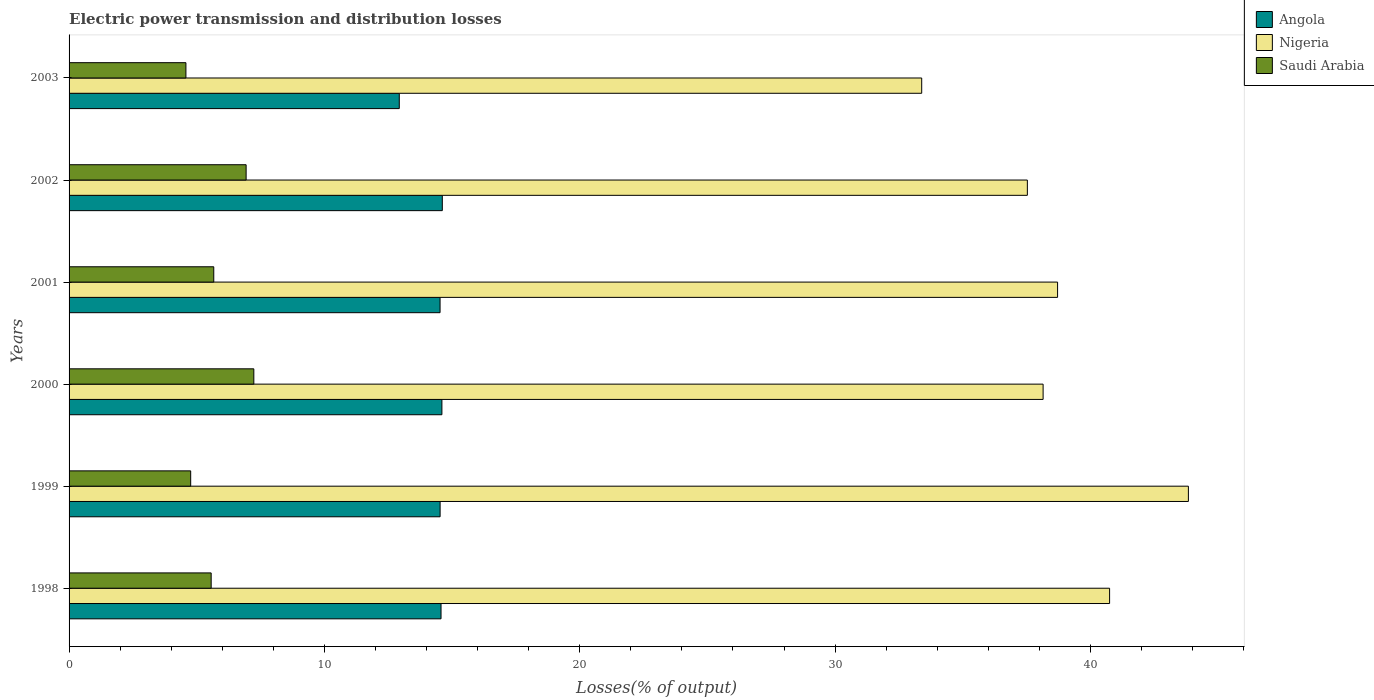How many different coloured bars are there?
Give a very brief answer. 3. How many groups of bars are there?
Offer a terse response. 6. Are the number of bars on each tick of the Y-axis equal?
Ensure brevity in your answer.  Yes. In how many cases, is the number of bars for a given year not equal to the number of legend labels?
Your answer should be compact. 0. What is the electric power transmission and distribution losses in Saudi Arabia in 2002?
Your answer should be very brief. 6.93. Across all years, what is the maximum electric power transmission and distribution losses in Saudi Arabia?
Your answer should be very brief. 7.24. Across all years, what is the minimum electric power transmission and distribution losses in Saudi Arabia?
Keep it short and to the point. 4.58. What is the total electric power transmission and distribution losses in Angola in the graph?
Your answer should be compact. 85.78. What is the difference between the electric power transmission and distribution losses in Saudi Arabia in 1999 and that in 2001?
Ensure brevity in your answer.  -0.9. What is the difference between the electric power transmission and distribution losses in Saudi Arabia in 1998 and the electric power transmission and distribution losses in Angola in 2002?
Make the answer very short. -9.05. What is the average electric power transmission and distribution losses in Saudi Arabia per year?
Your response must be concise. 5.79. In the year 1998, what is the difference between the electric power transmission and distribution losses in Angola and electric power transmission and distribution losses in Saudi Arabia?
Give a very brief answer. 9. What is the ratio of the electric power transmission and distribution losses in Nigeria in 2000 to that in 2001?
Your response must be concise. 0.99. What is the difference between the highest and the second highest electric power transmission and distribution losses in Saudi Arabia?
Your response must be concise. 0.3. What is the difference between the highest and the lowest electric power transmission and distribution losses in Nigeria?
Offer a very short reply. 10.44. In how many years, is the electric power transmission and distribution losses in Saudi Arabia greater than the average electric power transmission and distribution losses in Saudi Arabia taken over all years?
Provide a succinct answer. 2. What does the 2nd bar from the top in 2001 represents?
Offer a very short reply. Nigeria. What does the 2nd bar from the bottom in 2002 represents?
Provide a succinct answer. Nigeria. What is the difference between two consecutive major ticks on the X-axis?
Your answer should be compact. 10. Does the graph contain grids?
Provide a succinct answer. No. Where does the legend appear in the graph?
Provide a succinct answer. Top right. How many legend labels are there?
Ensure brevity in your answer.  3. What is the title of the graph?
Provide a succinct answer. Electric power transmission and distribution losses. What is the label or title of the X-axis?
Keep it short and to the point. Losses(% of output). What is the label or title of the Y-axis?
Provide a short and direct response. Years. What is the Losses(% of output) in Angola in 1998?
Your answer should be compact. 14.57. What is the Losses(% of output) in Nigeria in 1998?
Offer a very short reply. 40.75. What is the Losses(% of output) in Saudi Arabia in 1998?
Offer a very short reply. 5.57. What is the Losses(% of output) of Angola in 1999?
Your answer should be very brief. 14.53. What is the Losses(% of output) in Nigeria in 1999?
Keep it short and to the point. 43.84. What is the Losses(% of output) in Saudi Arabia in 1999?
Give a very brief answer. 4.76. What is the Losses(% of output) of Angola in 2000?
Keep it short and to the point. 14.6. What is the Losses(% of output) in Nigeria in 2000?
Keep it short and to the point. 38.15. What is the Losses(% of output) of Saudi Arabia in 2000?
Provide a succinct answer. 7.24. What is the Losses(% of output) of Angola in 2001?
Your answer should be compact. 14.53. What is the Losses(% of output) in Nigeria in 2001?
Offer a very short reply. 38.71. What is the Losses(% of output) of Saudi Arabia in 2001?
Your answer should be very brief. 5.67. What is the Losses(% of output) of Angola in 2002?
Your answer should be compact. 14.62. What is the Losses(% of output) of Nigeria in 2002?
Ensure brevity in your answer.  37.53. What is the Losses(% of output) of Saudi Arabia in 2002?
Make the answer very short. 6.93. What is the Losses(% of output) of Angola in 2003?
Ensure brevity in your answer.  12.93. What is the Losses(% of output) of Nigeria in 2003?
Offer a very short reply. 33.39. What is the Losses(% of output) in Saudi Arabia in 2003?
Ensure brevity in your answer.  4.58. Across all years, what is the maximum Losses(% of output) of Angola?
Your response must be concise. 14.62. Across all years, what is the maximum Losses(% of output) of Nigeria?
Provide a short and direct response. 43.84. Across all years, what is the maximum Losses(% of output) in Saudi Arabia?
Ensure brevity in your answer.  7.24. Across all years, what is the minimum Losses(% of output) of Angola?
Your answer should be very brief. 12.93. Across all years, what is the minimum Losses(% of output) of Nigeria?
Offer a terse response. 33.39. Across all years, what is the minimum Losses(% of output) of Saudi Arabia?
Your answer should be very brief. 4.58. What is the total Losses(% of output) of Angola in the graph?
Ensure brevity in your answer.  85.78. What is the total Losses(% of output) in Nigeria in the graph?
Ensure brevity in your answer.  232.37. What is the total Losses(% of output) in Saudi Arabia in the graph?
Provide a short and direct response. 34.74. What is the difference between the Losses(% of output) in Angola in 1998 and that in 1999?
Ensure brevity in your answer.  0.04. What is the difference between the Losses(% of output) in Nigeria in 1998 and that in 1999?
Your answer should be very brief. -3.09. What is the difference between the Losses(% of output) in Saudi Arabia in 1998 and that in 1999?
Your response must be concise. 0.8. What is the difference between the Losses(% of output) in Angola in 1998 and that in 2000?
Ensure brevity in your answer.  -0.03. What is the difference between the Losses(% of output) of Nigeria in 1998 and that in 2000?
Your answer should be compact. 2.6. What is the difference between the Losses(% of output) in Saudi Arabia in 1998 and that in 2000?
Offer a very short reply. -1.67. What is the difference between the Losses(% of output) in Angola in 1998 and that in 2001?
Your answer should be compact. 0.04. What is the difference between the Losses(% of output) in Nigeria in 1998 and that in 2001?
Keep it short and to the point. 2.04. What is the difference between the Losses(% of output) in Saudi Arabia in 1998 and that in 2001?
Your answer should be very brief. -0.1. What is the difference between the Losses(% of output) in Nigeria in 1998 and that in 2002?
Give a very brief answer. 3.22. What is the difference between the Losses(% of output) in Saudi Arabia in 1998 and that in 2002?
Provide a short and direct response. -1.37. What is the difference between the Losses(% of output) of Angola in 1998 and that in 2003?
Your response must be concise. 1.64. What is the difference between the Losses(% of output) in Nigeria in 1998 and that in 2003?
Ensure brevity in your answer.  7.36. What is the difference between the Losses(% of output) in Saudi Arabia in 1998 and that in 2003?
Your answer should be compact. 0.99. What is the difference between the Losses(% of output) of Angola in 1999 and that in 2000?
Offer a very short reply. -0.07. What is the difference between the Losses(% of output) in Nigeria in 1999 and that in 2000?
Offer a very short reply. 5.69. What is the difference between the Losses(% of output) of Saudi Arabia in 1999 and that in 2000?
Provide a short and direct response. -2.47. What is the difference between the Losses(% of output) of Angola in 1999 and that in 2001?
Your answer should be compact. 0. What is the difference between the Losses(% of output) in Nigeria in 1999 and that in 2001?
Your answer should be very brief. 5.12. What is the difference between the Losses(% of output) in Saudi Arabia in 1999 and that in 2001?
Offer a terse response. -0.9. What is the difference between the Losses(% of output) in Angola in 1999 and that in 2002?
Your answer should be very brief. -0.09. What is the difference between the Losses(% of output) of Nigeria in 1999 and that in 2002?
Offer a terse response. 6.31. What is the difference between the Losses(% of output) of Saudi Arabia in 1999 and that in 2002?
Offer a terse response. -2.17. What is the difference between the Losses(% of output) of Angola in 1999 and that in 2003?
Offer a terse response. 1.6. What is the difference between the Losses(% of output) of Nigeria in 1999 and that in 2003?
Offer a terse response. 10.44. What is the difference between the Losses(% of output) of Saudi Arabia in 1999 and that in 2003?
Offer a very short reply. 0.19. What is the difference between the Losses(% of output) of Angola in 2000 and that in 2001?
Ensure brevity in your answer.  0.07. What is the difference between the Losses(% of output) in Nigeria in 2000 and that in 2001?
Provide a short and direct response. -0.57. What is the difference between the Losses(% of output) in Saudi Arabia in 2000 and that in 2001?
Make the answer very short. 1.57. What is the difference between the Losses(% of output) of Angola in 2000 and that in 2002?
Provide a succinct answer. -0.02. What is the difference between the Losses(% of output) in Nigeria in 2000 and that in 2002?
Offer a terse response. 0.62. What is the difference between the Losses(% of output) of Saudi Arabia in 2000 and that in 2002?
Make the answer very short. 0.3. What is the difference between the Losses(% of output) of Angola in 2000 and that in 2003?
Your answer should be very brief. 1.67. What is the difference between the Losses(% of output) in Nigeria in 2000 and that in 2003?
Offer a very short reply. 4.75. What is the difference between the Losses(% of output) in Saudi Arabia in 2000 and that in 2003?
Provide a succinct answer. 2.66. What is the difference between the Losses(% of output) of Angola in 2001 and that in 2002?
Offer a very short reply. -0.09. What is the difference between the Losses(% of output) of Nigeria in 2001 and that in 2002?
Give a very brief answer. 1.18. What is the difference between the Losses(% of output) in Saudi Arabia in 2001 and that in 2002?
Your answer should be compact. -1.27. What is the difference between the Losses(% of output) of Angola in 2001 and that in 2003?
Your answer should be very brief. 1.6. What is the difference between the Losses(% of output) in Nigeria in 2001 and that in 2003?
Your response must be concise. 5.32. What is the difference between the Losses(% of output) of Saudi Arabia in 2001 and that in 2003?
Your answer should be compact. 1.09. What is the difference between the Losses(% of output) of Angola in 2002 and that in 2003?
Provide a succinct answer. 1.69. What is the difference between the Losses(% of output) in Nigeria in 2002 and that in 2003?
Your answer should be compact. 4.14. What is the difference between the Losses(% of output) of Saudi Arabia in 2002 and that in 2003?
Offer a very short reply. 2.36. What is the difference between the Losses(% of output) of Angola in 1998 and the Losses(% of output) of Nigeria in 1999?
Offer a very short reply. -29.27. What is the difference between the Losses(% of output) in Angola in 1998 and the Losses(% of output) in Saudi Arabia in 1999?
Keep it short and to the point. 9.8. What is the difference between the Losses(% of output) of Nigeria in 1998 and the Losses(% of output) of Saudi Arabia in 1999?
Your answer should be compact. 35.99. What is the difference between the Losses(% of output) in Angola in 1998 and the Losses(% of output) in Nigeria in 2000?
Your response must be concise. -23.58. What is the difference between the Losses(% of output) of Angola in 1998 and the Losses(% of output) of Saudi Arabia in 2000?
Give a very brief answer. 7.33. What is the difference between the Losses(% of output) of Nigeria in 1998 and the Losses(% of output) of Saudi Arabia in 2000?
Provide a succinct answer. 33.52. What is the difference between the Losses(% of output) of Angola in 1998 and the Losses(% of output) of Nigeria in 2001?
Your answer should be very brief. -24.15. What is the difference between the Losses(% of output) in Angola in 1998 and the Losses(% of output) in Saudi Arabia in 2001?
Offer a terse response. 8.9. What is the difference between the Losses(% of output) of Nigeria in 1998 and the Losses(% of output) of Saudi Arabia in 2001?
Keep it short and to the point. 35.09. What is the difference between the Losses(% of output) of Angola in 1998 and the Losses(% of output) of Nigeria in 2002?
Your response must be concise. -22.96. What is the difference between the Losses(% of output) of Angola in 1998 and the Losses(% of output) of Saudi Arabia in 2002?
Make the answer very short. 7.63. What is the difference between the Losses(% of output) of Nigeria in 1998 and the Losses(% of output) of Saudi Arabia in 2002?
Your response must be concise. 33.82. What is the difference between the Losses(% of output) of Angola in 1998 and the Losses(% of output) of Nigeria in 2003?
Offer a terse response. -18.83. What is the difference between the Losses(% of output) in Angola in 1998 and the Losses(% of output) in Saudi Arabia in 2003?
Provide a succinct answer. 9.99. What is the difference between the Losses(% of output) in Nigeria in 1998 and the Losses(% of output) in Saudi Arabia in 2003?
Keep it short and to the point. 36.18. What is the difference between the Losses(% of output) in Angola in 1999 and the Losses(% of output) in Nigeria in 2000?
Keep it short and to the point. -23.62. What is the difference between the Losses(% of output) of Angola in 1999 and the Losses(% of output) of Saudi Arabia in 2000?
Provide a short and direct response. 7.3. What is the difference between the Losses(% of output) in Nigeria in 1999 and the Losses(% of output) in Saudi Arabia in 2000?
Ensure brevity in your answer.  36.6. What is the difference between the Losses(% of output) of Angola in 1999 and the Losses(% of output) of Nigeria in 2001?
Your answer should be compact. -24.18. What is the difference between the Losses(% of output) of Angola in 1999 and the Losses(% of output) of Saudi Arabia in 2001?
Your answer should be very brief. 8.87. What is the difference between the Losses(% of output) of Nigeria in 1999 and the Losses(% of output) of Saudi Arabia in 2001?
Keep it short and to the point. 38.17. What is the difference between the Losses(% of output) in Angola in 1999 and the Losses(% of output) in Nigeria in 2002?
Your answer should be compact. -23. What is the difference between the Losses(% of output) of Angola in 1999 and the Losses(% of output) of Saudi Arabia in 2002?
Your answer should be compact. 7.6. What is the difference between the Losses(% of output) in Nigeria in 1999 and the Losses(% of output) in Saudi Arabia in 2002?
Make the answer very short. 36.9. What is the difference between the Losses(% of output) in Angola in 1999 and the Losses(% of output) in Nigeria in 2003?
Your answer should be compact. -18.86. What is the difference between the Losses(% of output) of Angola in 1999 and the Losses(% of output) of Saudi Arabia in 2003?
Offer a terse response. 9.96. What is the difference between the Losses(% of output) in Nigeria in 1999 and the Losses(% of output) in Saudi Arabia in 2003?
Offer a very short reply. 39.26. What is the difference between the Losses(% of output) in Angola in 2000 and the Losses(% of output) in Nigeria in 2001?
Give a very brief answer. -24.11. What is the difference between the Losses(% of output) of Angola in 2000 and the Losses(% of output) of Saudi Arabia in 2001?
Your answer should be compact. 8.94. What is the difference between the Losses(% of output) in Nigeria in 2000 and the Losses(% of output) in Saudi Arabia in 2001?
Keep it short and to the point. 32.48. What is the difference between the Losses(% of output) of Angola in 2000 and the Losses(% of output) of Nigeria in 2002?
Keep it short and to the point. -22.93. What is the difference between the Losses(% of output) of Angola in 2000 and the Losses(% of output) of Saudi Arabia in 2002?
Keep it short and to the point. 7.67. What is the difference between the Losses(% of output) in Nigeria in 2000 and the Losses(% of output) in Saudi Arabia in 2002?
Your answer should be compact. 31.21. What is the difference between the Losses(% of output) in Angola in 2000 and the Losses(% of output) in Nigeria in 2003?
Your answer should be very brief. -18.79. What is the difference between the Losses(% of output) in Angola in 2000 and the Losses(% of output) in Saudi Arabia in 2003?
Give a very brief answer. 10.03. What is the difference between the Losses(% of output) of Nigeria in 2000 and the Losses(% of output) of Saudi Arabia in 2003?
Your answer should be very brief. 33.57. What is the difference between the Losses(% of output) of Angola in 2001 and the Losses(% of output) of Nigeria in 2002?
Offer a very short reply. -23. What is the difference between the Losses(% of output) in Angola in 2001 and the Losses(% of output) in Saudi Arabia in 2002?
Your answer should be very brief. 7.6. What is the difference between the Losses(% of output) of Nigeria in 2001 and the Losses(% of output) of Saudi Arabia in 2002?
Provide a succinct answer. 31.78. What is the difference between the Losses(% of output) of Angola in 2001 and the Losses(% of output) of Nigeria in 2003?
Ensure brevity in your answer.  -18.86. What is the difference between the Losses(% of output) in Angola in 2001 and the Losses(% of output) in Saudi Arabia in 2003?
Your answer should be very brief. 9.95. What is the difference between the Losses(% of output) in Nigeria in 2001 and the Losses(% of output) in Saudi Arabia in 2003?
Make the answer very short. 34.14. What is the difference between the Losses(% of output) in Angola in 2002 and the Losses(% of output) in Nigeria in 2003?
Give a very brief answer. -18.78. What is the difference between the Losses(% of output) in Angola in 2002 and the Losses(% of output) in Saudi Arabia in 2003?
Make the answer very short. 10.04. What is the difference between the Losses(% of output) of Nigeria in 2002 and the Losses(% of output) of Saudi Arabia in 2003?
Provide a succinct answer. 32.95. What is the average Losses(% of output) in Angola per year?
Provide a succinct answer. 14.3. What is the average Losses(% of output) of Nigeria per year?
Your answer should be compact. 38.73. What is the average Losses(% of output) in Saudi Arabia per year?
Make the answer very short. 5.79. In the year 1998, what is the difference between the Losses(% of output) of Angola and Losses(% of output) of Nigeria?
Your response must be concise. -26.18. In the year 1998, what is the difference between the Losses(% of output) in Angola and Losses(% of output) in Saudi Arabia?
Offer a very short reply. 9. In the year 1998, what is the difference between the Losses(% of output) in Nigeria and Losses(% of output) in Saudi Arabia?
Your answer should be very brief. 35.19. In the year 1999, what is the difference between the Losses(% of output) in Angola and Losses(% of output) in Nigeria?
Provide a succinct answer. -29.31. In the year 1999, what is the difference between the Losses(% of output) of Angola and Losses(% of output) of Saudi Arabia?
Make the answer very short. 9.77. In the year 1999, what is the difference between the Losses(% of output) of Nigeria and Losses(% of output) of Saudi Arabia?
Offer a terse response. 39.07. In the year 2000, what is the difference between the Losses(% of output) in Angola and Losses(% of output) in Nigeria?
Your answer should be compact. -23.55. In the year 2000, what is the difference between the Losses(% of output) in Angola and Losses(% of output) in Saudi Arabia?
Offer a terse response. 7.37. In the year 2000, what is the difference between the Losses(% of output) of Nigeria and Losses(% of output) of Saudi Arabia?
Offer a terse response. 30.91. In the year 2001, what is the difference between the Losses(% of output) of Angola and Losses(% of output) of Nigeria?
Make the answer very short. -24.18. In the year 2001, what is the difference between the Losses(% of output) of Angola and Losses(% of output) of Saudi Arabia?
Your answer should be very brief. 8.86. In the year 2001, what is the difference between the Losses(% of output) in Nigeria and Losses(% of output) in Saudi Arabia?
Ensure brevity in your answer.  33.05. In the year 2002, what is the difference between the Losses(% of output) of Angola and Losses(% of output) of Nigeria?
Your answer should be compact. -22.91. In the year 2002, what is the difference between the Losses(% of output) in Angola and Losses(% of output) in Saudi Arabia?
Provide a short and direct response. 7.68. In the year 2002, what is the difference between the Losses(% of output) in Nigeria and Losses(% of output) in Saudi Arabia?
Give a very brief answer. 30.6. In the year 2003, what is the difference between the Losses(% of output) of Angola and Losses(% of output) of Nigeria?
Your answer should be compact. -20.46. In the year 2003, what is the difference between the Losses(% of output) in Angola and Losses(% of output) in Saudi Arabia?
Make the answer very short. 8.36. In the year 2003, what is the difference between the Losses(% of output) of Nigeria and Losses(% of output) of Saudi Arabia?
Give a very brief answer. 28.82. What is the ratio of the Losses(% of output) in Nigeria in 1998 to that in 1999?
Your answer should be very brief. 0.93. What is the ratio of the Losses(% of output) in Saudi Arabia in 1998 to that in 1999?
Offer a terse response. 1.17. What is the ratio of the Losses(% of output) of Nigeria in 1998 to that in 2000?
Your answer should be very brief. 1.07. What is the ratio of the Losses(% of output) in Saudi Arabia in 1998 to that in 2000?
Ensure brevity in your answer.  0.77. What is the ratio of the Losses(% of output) of Nigeria in 1998 to that in 2001?
Offer a very short reply. 1.05. What is the ratio of the Losses(% of output) in Saudi Arabia in 1998 to that in 2001?
Your response must be concise. 0.98. What is the ratio of the Losses(% of output) of Nigeria in 1998 to that in 2002?
Give a very brief answer. 1.09. What is the ratio of the Losses(% of output) of Saudi Arabia in 1998 to that in 2002?
Give a very brief answer. 0.8. What is the ratio of the Losses(% of output) of Angola in 1998 to that in 2003?
Provide a succinct answer. 1.13. What is the ratio of the Losses(% of output) of Nigeria in 1998 to that in 2003?
Make the answer very short. 1.22. What is the ratio of the Losses(% of output) in Saudi Arabia in 1998 to that in 2003?
Provide a short and direct response. 1.22. What is the ratio of the Losses(% of output) in Nigeria in 1999 to that in 2000?
Give a very brief answer. 1.15. What is the ratio of the Losses(% of output) of Saudi Arabia in 1999 to that in 2000?
Provide a succinct answer. 0.66. What is the ratio of the Losses(% of output) of Nigeria in 1999 to that in 2001?
Your answer should be compact. 1.13. What is the ratio of the Losses(% of output) of Saudi Arabia in 1999 to that in 2001?
Your answer should be very brief. 0.84. What is the ratio of the Losses(% of output) of Angola in 1999 to that in 2002?
Offer a very short reply. 0.99. What is the ratio of the Losses(% of output) in Nigeria in 1999 to that in 2002?
Your answer should be compact. 1.17. What is the ratio of the Losses(% of output) of Saudi Arabia in 1999 to that in 2002?
Ensure brevity in your answer.  0.69. What is the ratio of the Losses(% of output) in Angola in 1999 to that in 2003?
Keep it short and to the point. 1.12. What is the ratio of the Losses(% of output) of Nigeria in 1999 to that in 2003?
Give a very brief answer. 1.31. What is the ratio of the Losses(% of output) of Saudi Arabia in 1999 to that in 2003?
Offer a very short reply. 1.04. What is the ratio of the Losses(% of output) of Angola in 2000 to that in 2001?
Make the answer very short. 1. What is the ratio of the Losses(% of output) in Nigeria in 2000 to that in 2001?
Provide a succinct answer. 0.99. What is the ratio of the Losses(% of output) in Saudi Arabia in 2000 to that in 2001?
Provide a short and direct response. 1.28. What is the ratio of the Losses(% of output) in Angola in 2000 to that in 2002?
Offer a terse response. 1. What is the ratio of the Losses(% of output) of Nigeria in 2000 to that in 2002?
Provide a short and direct response. 1.02. What is the ratio of the Losses(% of output) in Saudi Arabia in 2000 to that in 2002?
Offer a very short reply. 1.04. What is the ratio of the Losses(% of output) of Angola in 2000 to that in 2003?
Offer a terse response. 1.13. What is the ratio of the Losses(% of output) in Nigeria in 2000 to that in 2003?
Offer a very short reply. 1.14. What is the ratio of the Losses(% of output) in Saudi Arabia in 2000 to that in 2003?
Give a very brief answer. 1.58. What is the ratio of the Losses(% of output) in Angola in 2001 to that in 2002?
Offer a terse response. 0.99. What is the ratio of the Losses(% of output) in Nigeria in 2001 to that in 2002?
Give a very brief answer. 1.03. What is the ratio of the Losses(% of output) in Saudi Arabia in 2001 to that in 2002?
Offer a terse response. 0.82. What is the ratio of the Losses(% of output) in Angola in 2001 to that in 2003?
Ensure brevity in your answer.  1.12. What is the ratio of the Losses(% of output) in Nigeria in 2001 to that in 2003?
Give a very brief answer. 1.16. What is the ratio of the Losses(% of output) of Saudi Arabia in 2001 to that in 2003?
Provide a short and direct response. 1.24. What is the ratio of the Losses(% of output) of Angola in 2002 to that in 2003?
Make the answer very short. 1.13. What is the ratio of the Losses(% of output) of Nigeria in 2002 to that in 2003?
Your response must be concise. 1.12. What is the ratio of the Losses(% of output) of Saudi Arabia in 2002 to that in 2003?
Give a very brief answer. 1.52. What is the difference between the highest and the second highest Losses(% of output) in Angola?
Your response must be concise. 0.02. What is the difference between the highest and the second highest Losses(% of output) in Nigeria?
Provide a succinct answer. 3.09. What is the difference between the highest and the second highest Losses(% of output) in Saudi Arabia?
Your answer should be compact. 0.3. What is the difference between the highest and the lowest Losses(% of output) of Angola?
Make the answer very short. 1.69. What is the difference between the highest and the lowest Losses(% of output) of Nigeria?
Your answer should be compact. 10.44. What is the difference between the highest and the lowest Losses(% of output) in Saudi Arabia?
Provide a succinct answer. 2.66. 